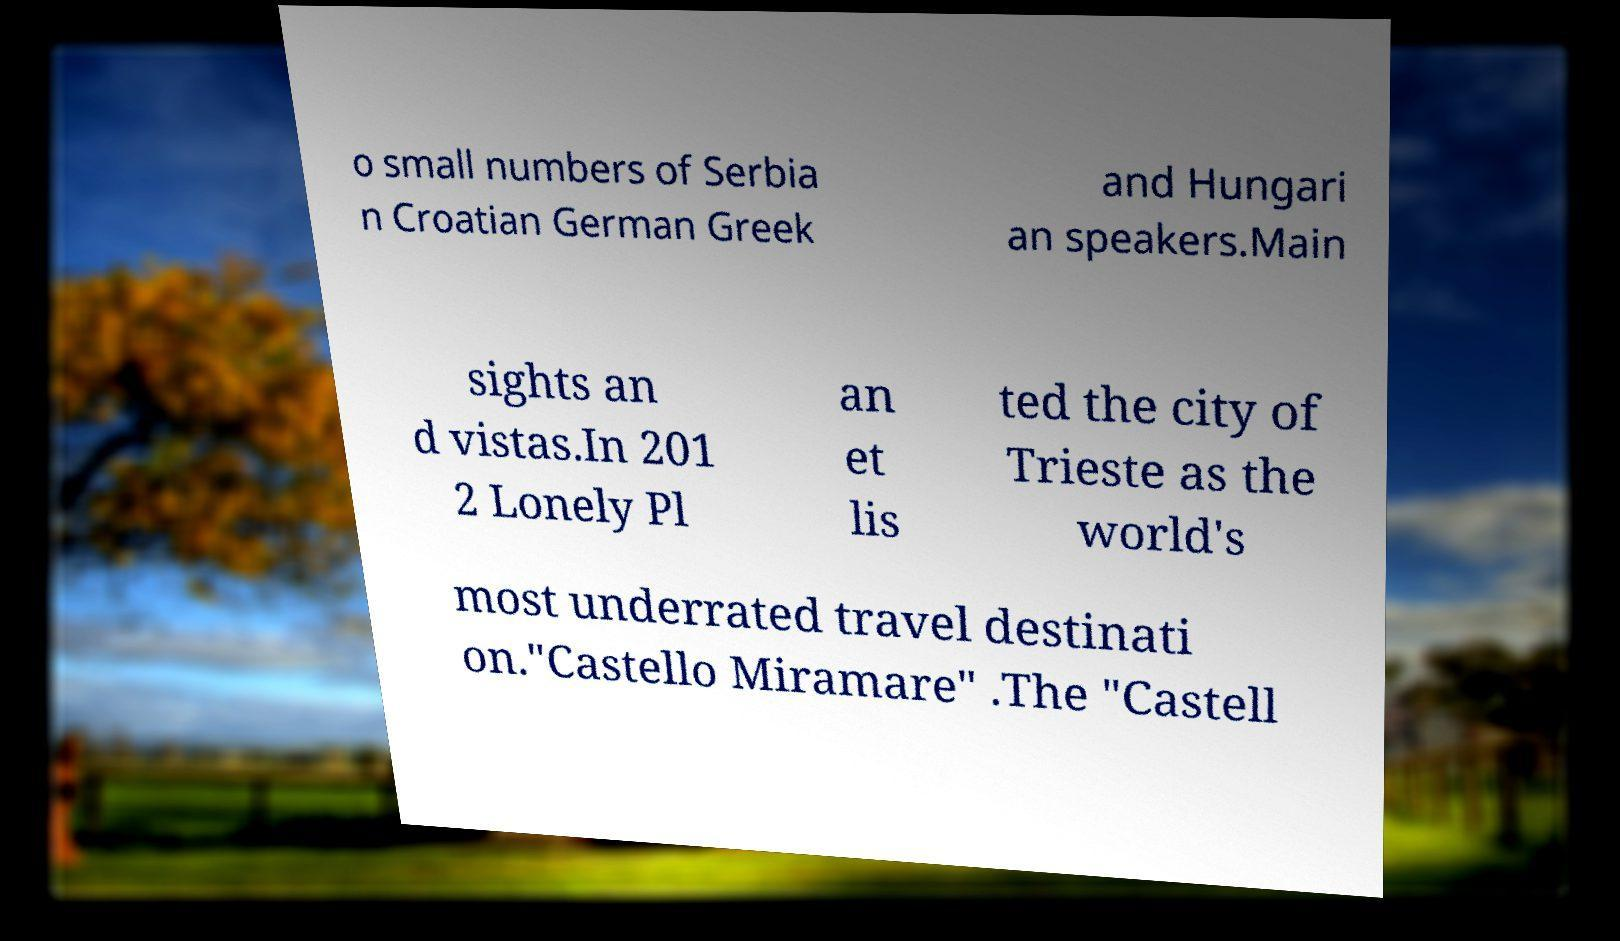Please read and relay the text visible in this image. What does it say? o small numbers of Serbia n Croatian German Greek and Hungari an speakers.Main sights an d vistas.In 201 2 Lonely Pl an et lis ted the city of Trieste as the world's most underrated travel destinati on."Castello Miramare" .The "Castell 